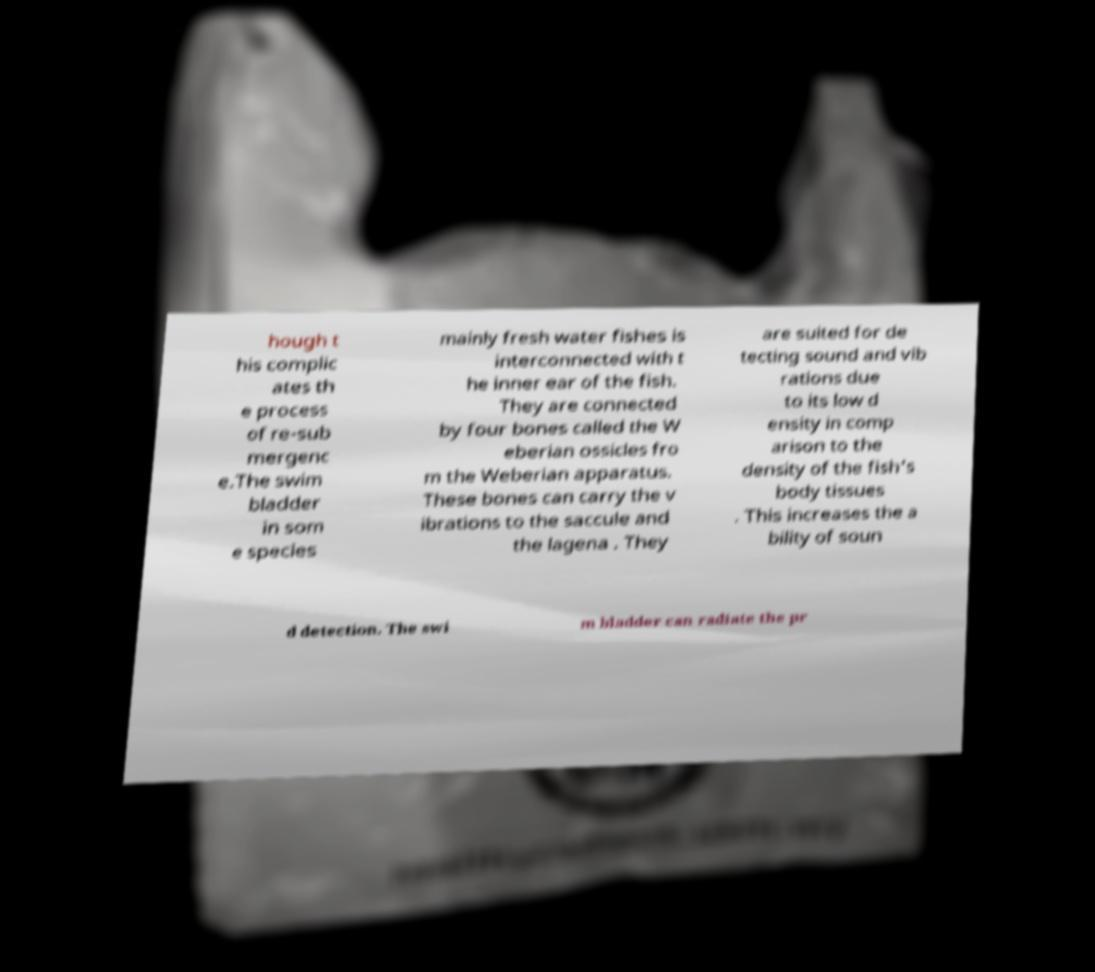What messages or text are displayed in this image? I need them in a readable, typed format. hough t his complic ates th e process of re-sub mergenc e.The swim bladder in som e species mainly fresh water fishes is interconnected with t he inner ear of the fish. They are connected by four bones called the W eberian ossicles fro m the Weberian apparatus. These bones can carry the v ibrations to the saccule and the lagena . They are suited for de tecting sound and vib rations due to its low d ensity in comp arison to the density of the fish's body tissues . This increases the a bility of soun d detection. The swi m bladder can radiate the pr 